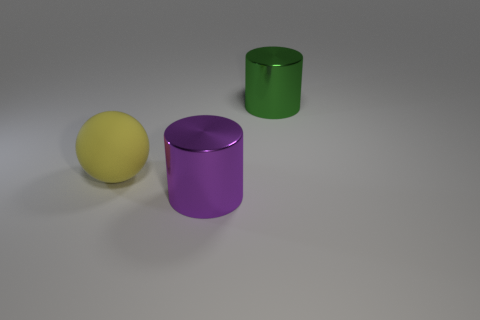Are there any metal things that have the same shape as the matte thing?
Your answer should be compact. No. The purple shiny thing is what shape?
Your response must be concise. Cylinder. Are there more metal cylinders that are in front of the rubber ball than large yellow spheres that are behind the purple metallic cylinder?
Make the answer very short. No. The big object that is both behind the big purple shiny object and on the right side of the large yellow thing is made of what material?
Offer a terse response. Metal. What material is the other large thing that is the same shape as the big green object?
Your answer should be very brief. Metal. How many big green objects are behind the yellow rubber object that is behind the cylinder that is on the left side of the large green cylinder?
Your answer should be compact. 1. Is there anything else of the same color as the matte object?
Give a very brief answer. No. What number of big objects are behind the big purple object and in front of the big green cylinder?
Keep it short and to the point. 1. Does the green shiny object that is on the right side of the yellow matte thing have the same size as the object that is left of the big purple metallic thing?
Your answer should be very brief. Yes. How many things are either large things behind the big purple metallic object or large cyan rubber cylinders?
Make the answer very short. 2. 